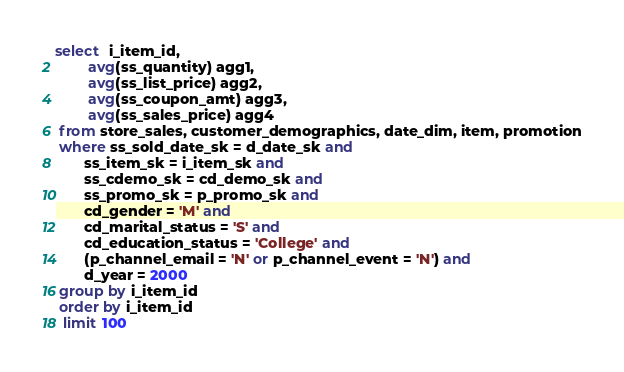Convert code to text. <code><loc_0><loc_0><loc_500><loc_500><_SQL_>select  i_item_id,
        avg(ss_quantity) agg1,
        avg(ss_list_price) agg2,
        avg(ss_coupon_amt) agg3,
        avg(ss_sales_price) agg4 
 from store_sales, customer_demographics, date_dim, item, promotion
 where ss_sold_date_sk = d_date_sk and
       ss_item_sk = i_item_sk and
       ss_cdemo_sk = cd_demo_sk and
       ss_promo_sk = p_promo_sk and
       cd_gender = 'M' and 
       cd_marital_status = 'S' and
       cd_education_status = 'College' and
       (p_channel_email = 'N' or p_channel_event = 'N') and
       d_year = 2000 
 group by i_item_id
 order by i_item_id
  limit 100
</code> 